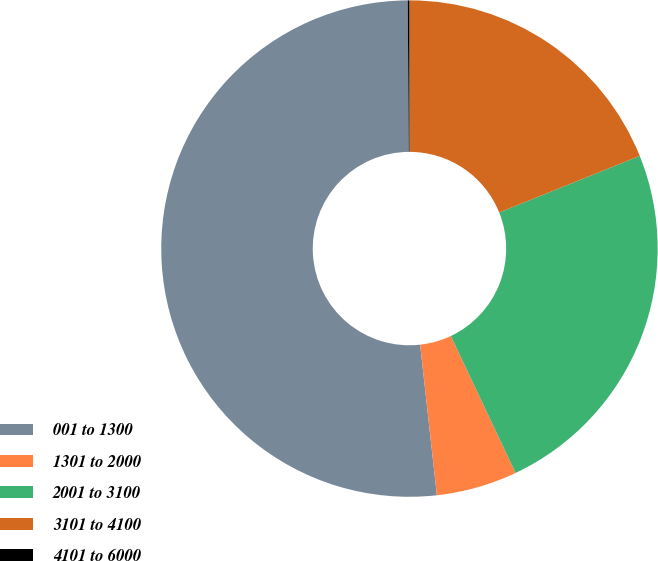Convert chart. <chart><loc_0><loc_0><loc_500><loc_500><pie_chart><fcel>001 to 1300<fcel>1301 to 2000<fcel>2001 to 3100<fcel>3101 to 4100<fcel>4101 to 6000<nl><fcel>51.65%<fcel>5.27%<fcel>24.06%<fcel>18.91%<fcel>0.11%<nl></chart> 